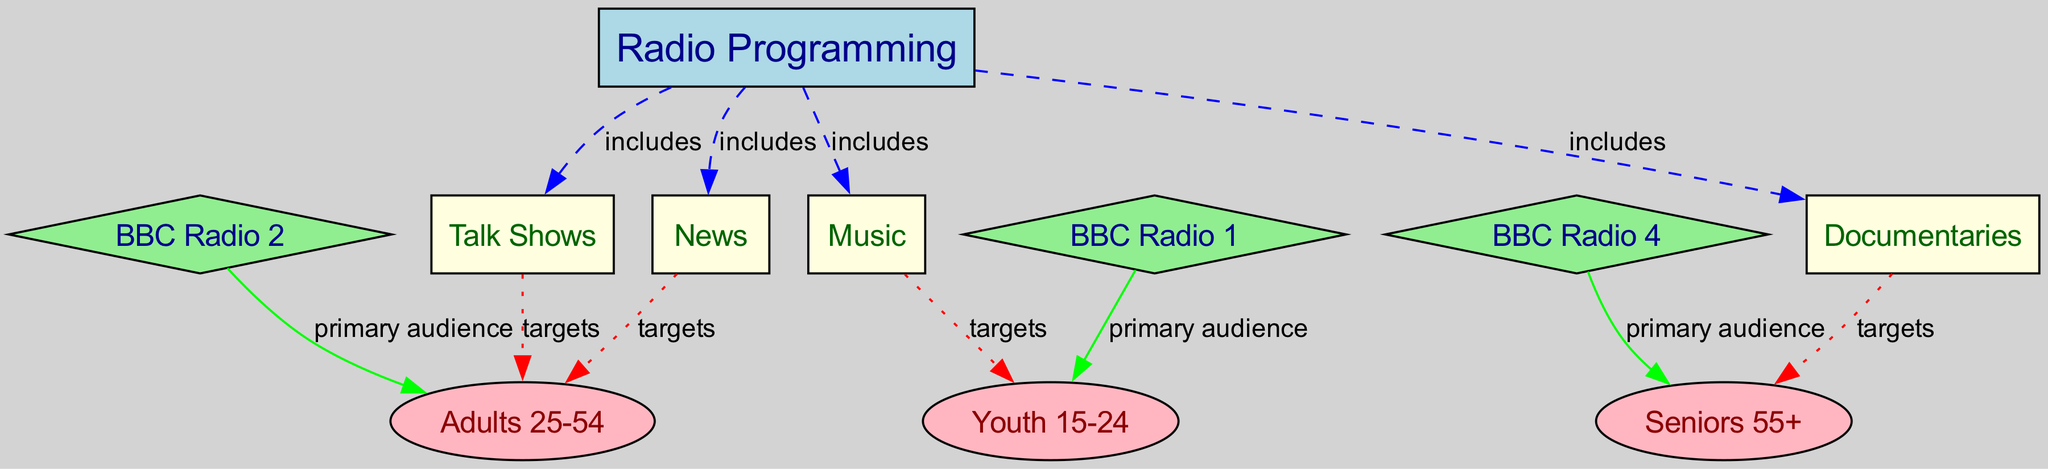What are the main genres of radio programming? The main genres listed in the diagram are News, Music, Talk Shows, and Documentaries. These genres are directly connected to the central node "Radio Programming" with 'includes' edges.
Answer: News, Music, Talk Shows, Documentaries Which age group is targeted by music programming? In the diagram, music programming has a dotted edge connecting it to the Youth (15-24) node, indicating that it targets this age group.
Answer: Youth 15-24 How many nodes are present in the diagram? By counting the nodes listed, including "Radio Programming", genres, age groups, and BBC stations, there are a total of 11 nodes in the diagram.
Answer: 11 Which BBC radio station primarily targets adults? The diagram connects "BBC Radio 2" with the Adults (25-54) node, indicating that this station's primary audience is adults.
Answer: BBC Radio 2 What is the relationship between documentaries and seniors? The 'targets' relationship is shown by a dotted edge from the Documentaries node to the Seniors (55+) node, indicating this programming specifically aims at seniors.
Answer: targets Which programming genre is associated with the BBC Radio 1? The diagram states that BBC Radio 1 has a primary audience of Youth (15-24) through a direct connection, indicating that it focuses on this demographic.
Answer: Youth 15-24 What type of edge connects news to adults? The edge between News and Adults (25-54) is labeled 'targets' and is represented as a dotted line in the diagram, signifying a targeting relationship.
Answer: targets Which radio programming genre is not aimed at youth? Documentaries are targeted towards the Seniors (55+) group, making them a programming genre that is not aimed at youth.
Answer: Documentaries What is the primary audience for BBC Radio 4? The diagram specifies that the primary audience for BBC Radio 4 is Seniors (55+) through a direct connection.
Answer: Seniors 55+ 